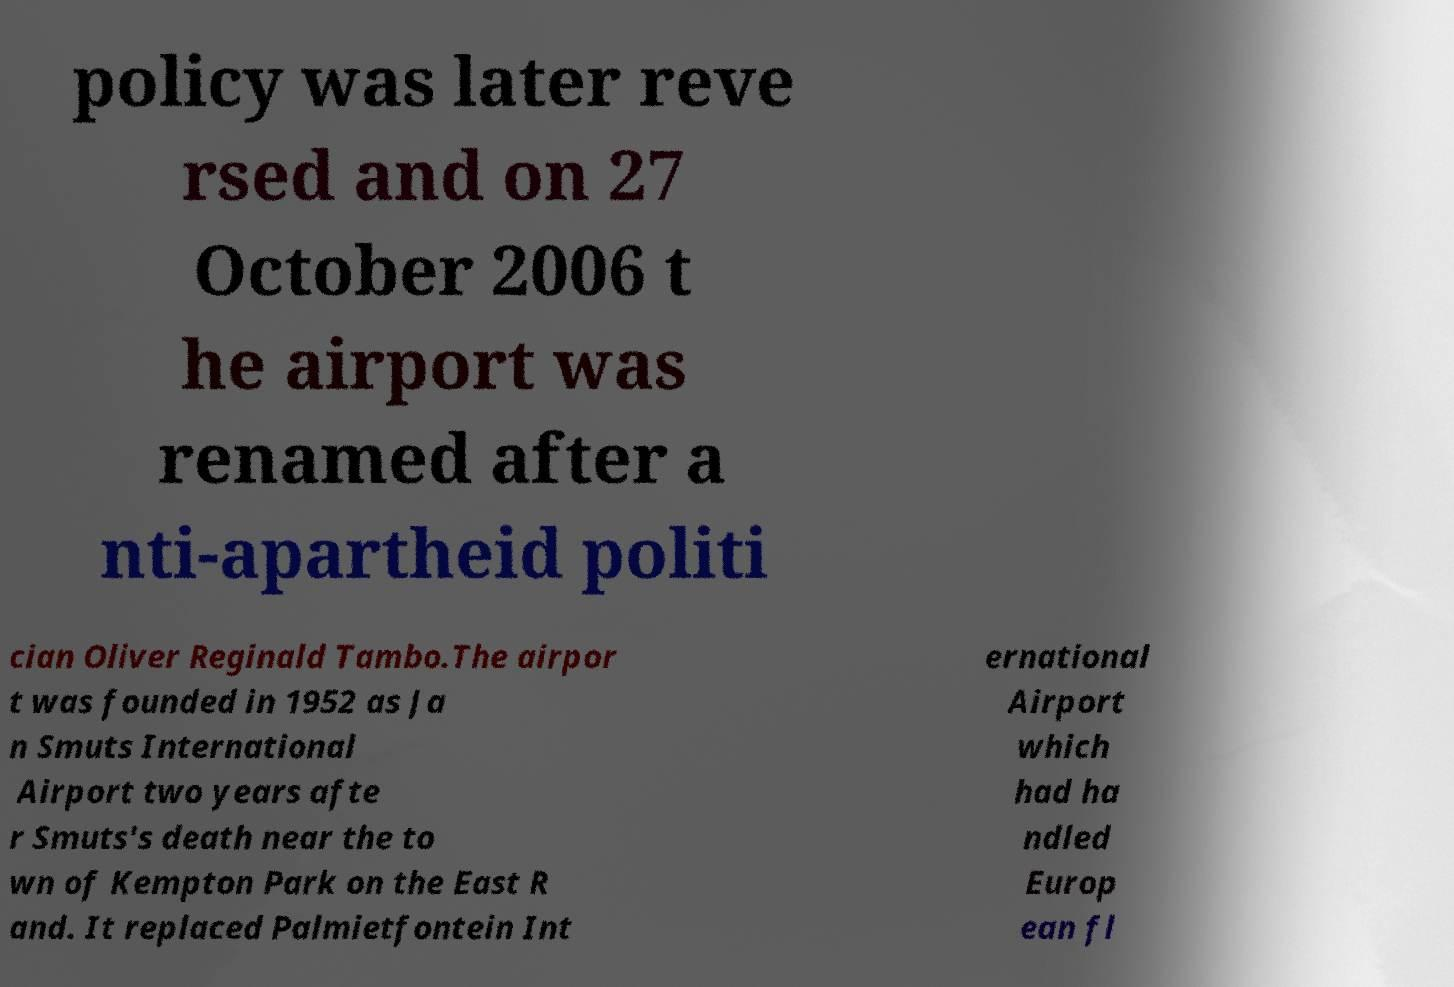Could you extract and type out the text from this image? policy was later reve rsed and on 27 October 2006 t he airport was renamed after a nti-apartheid politi cian Oliver Reginald Tambo.The airpor t was founded in 1952 as Ja n Smuts International Airport two years afte r Smuts's death near the to wn of Kempton Park on the East R and. It replaced Palmietfontein Int ernational Airport which had ha ndled Europ ean fl 